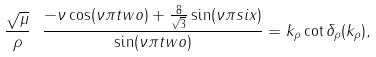Convert formula to latex. <formula><loc_0><loc_0><loc_500><loc_500>\frac { \sqrt { \mu } } { \rho } \ \frac { - \nu \cos ( \nu \pi t w o ) + \frac { 8 } { \sqrt { 3 } } \sin ( \nu \pi s i x ) } { \sin ( \nu \pi t w o ) } = k _ { \rho } \cot \delta _ { \rho } ( k _ { \rho } ) ,</formula> 